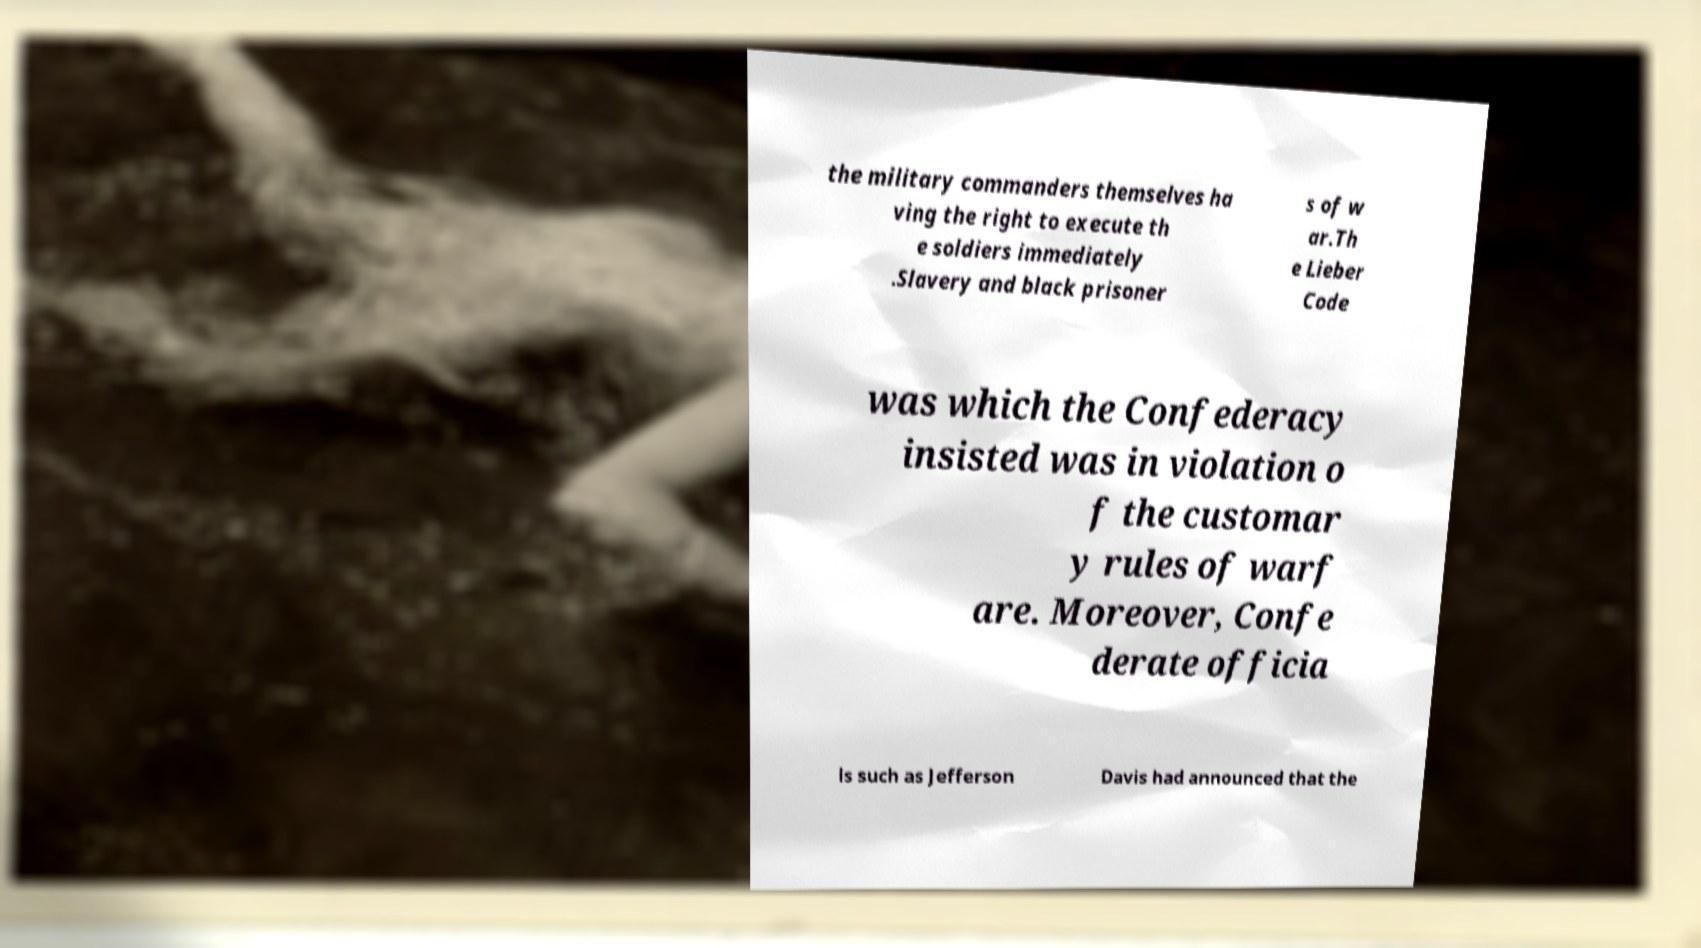For documentation purposes, I need the text within this image transcribed. Could you provide that? the military commanders themselves ha ving the right to execute th e soldiers immediately .Slavery and black prisoner s of w ar.Th e Lieber Code was which the Confederacy insisted was in violation o f the customar y rules of warf are. Moreover, Confe derate officia ls such as Jefferson Davis had announced that the 